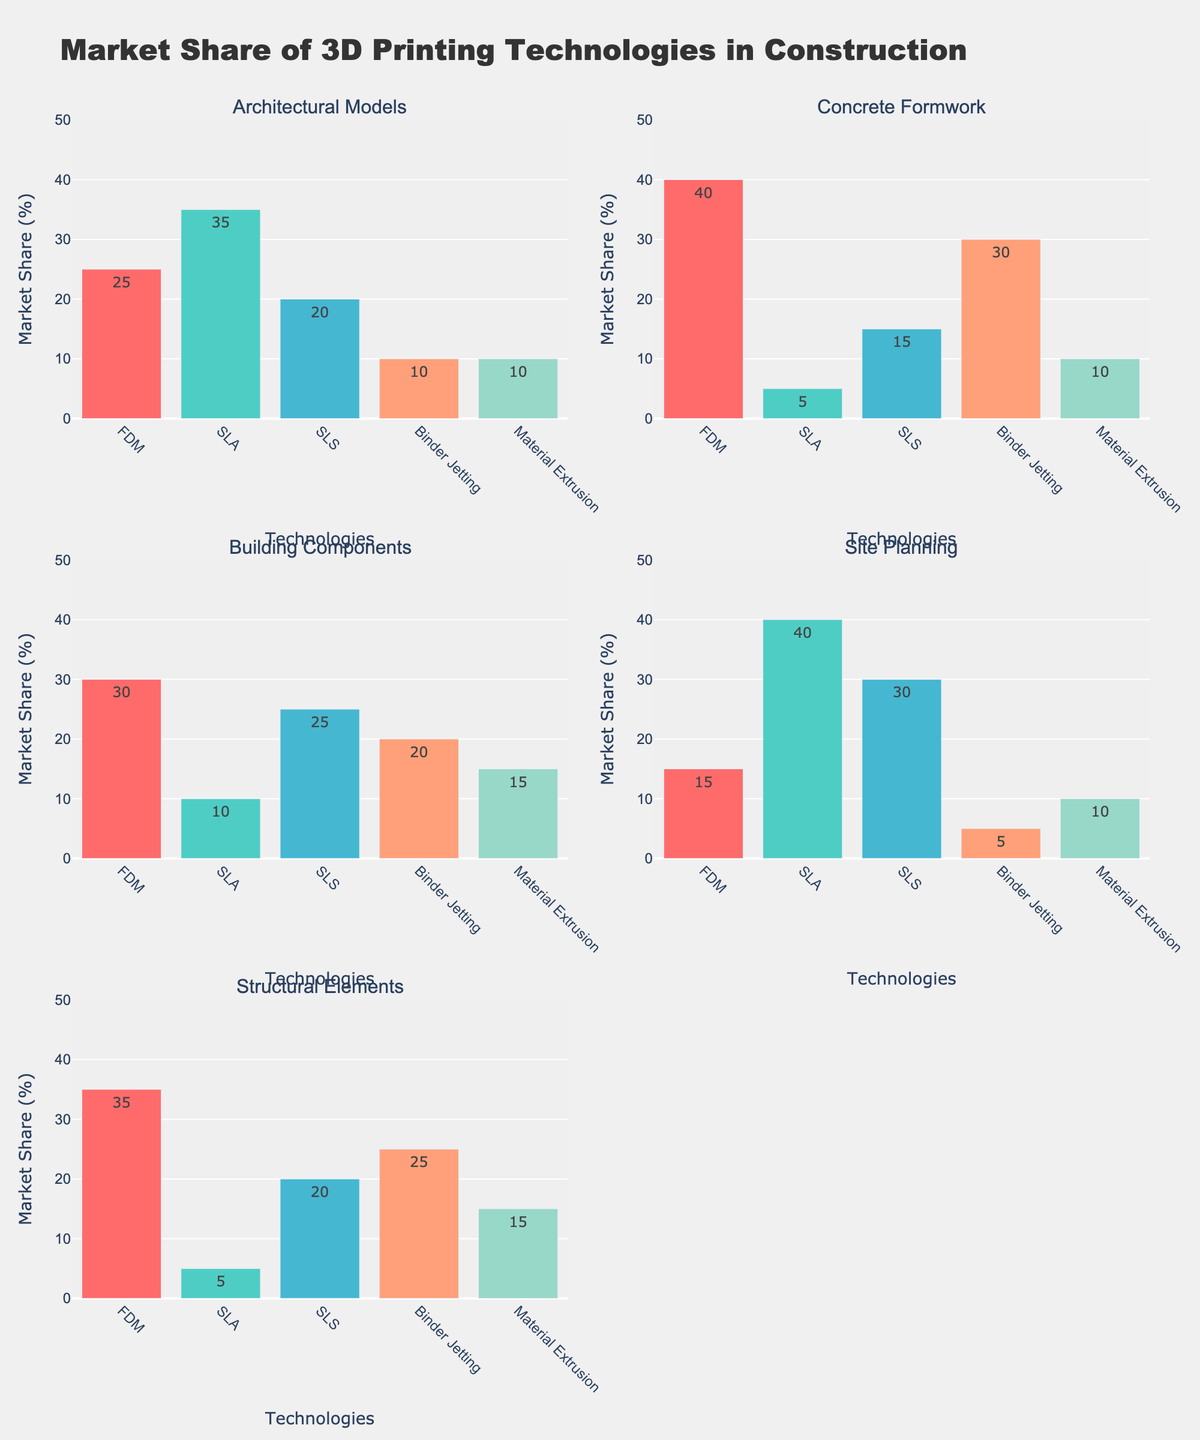Which application area has the highest market share for FDM technology? Look at each sub-plot for the bar representing FDM. The highest bar is for Concrete Formwork.
Answer: Concrete Formwork What is the total market share of SLA technology across all applications? Sum the values of SLA technology for each application: 35 (Architectural Models) + 5 (Concrete Formwork) + 10 (Building Components) + 40 (Site Planning) + 5 (Structural Elements). The total is 95.
Answer: 95 Which 3D printing technology dominates the Site Planning application? Compare the bars in the Site Planning subplot. The tallest bar is for SLA technology.
Answer: SLA technology How does the market share of Binder Jetting in Architectural Models compare to its market share in Structural Elements? Observe the Binder Jetting bars in both subplots. For Architectural Models, it is 10. For Structural Elements, it is 25. So, Binder Jetting has a higher market share in Structural Elements.
Answer: Higher in Structural Elements What is the average market share of Material Extrusion technology in all application areas? Add the values for Material Extrusion in all applications and divide by the number of applications: (10 + 10 + 15 + 10 + 15) / 5 = 12.
Answer: 12 Which application has the most evenly distributed market share among the 3D printing technologies? Look for the subplot where the bars are most similar in height. Building Components has more evenly distributed shares (30, 10, 25, 20, 15) compared to others.
Answer: Building Components In which application does FDM have the largest absolute market share, and what is that share? Identify the highest bar for FDM in the subplots. FDM has the highest share in Concrete Formwork, which is 40.
Answer: Concrete Formwork, 40 Is the market share of SLS technology greater in Building Components or Site Planning? Compare the bars for SLS in Building Components and Site Planning. Building Components has a share of 25 while Site Planning has 30.
Answer: Greater in Site Planning What is the difference between the market share of the leading technology and the second leading technology in Structural Elements? Identify the top two highest bars for Structural Elements: 35 (FDM) and 25 (Binder Jetting). The difference is 35 - 25 = 10.
Answer: 10 Which technologies have a market share of 15 in any application? Scan through all subplots and identify where any bar is at 15: FDM in Concrete Formwork, Material Extrusion in Concrete Formwork, Material Extrusion in Structural Elements.
Answer: FDM, Material Extrusion 